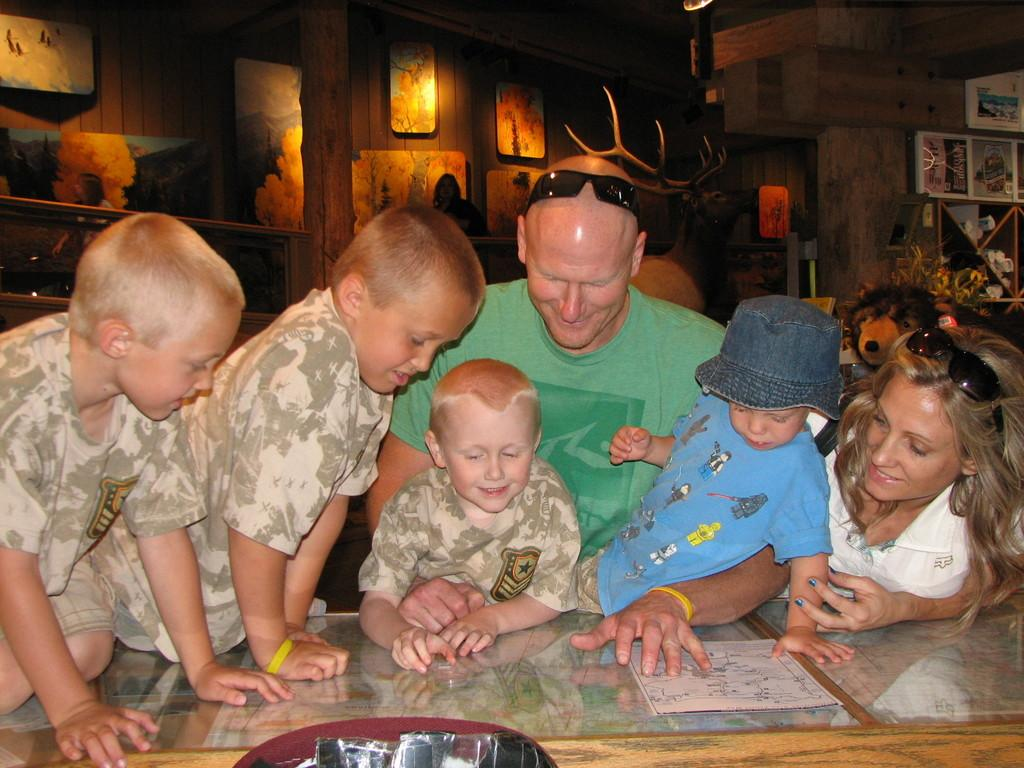Who or what can be seen in the image? There are people in the image. What is on the glass table in the image? There is a poster on a glass table. What else can be seen in the image besides the people and poster? There are objects visible in the image. What can be seen in the background of the image? In the background of the image, there are animals, frames, and people, as well as additional objects. What type of waste is being disposed of in the image? There is no waste being disposed of in the image. What is the tendency of the potato in the image? There is no potato present in the image, so it is not possible to determine its tendency. 